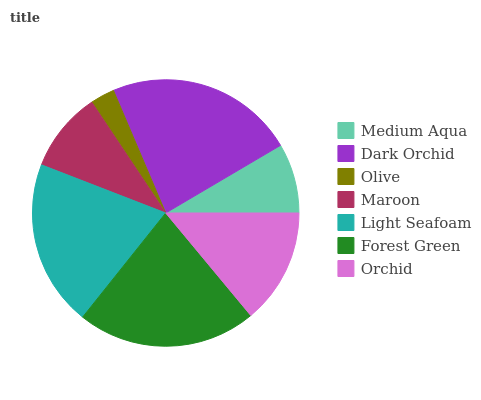Is Olive the minimum?
Answer yes or no. Yes. Is Dark Orchid the maximum?
Answer yes or no. Yes. Is Dark Orchid the minimum?
Answer yes or no. No. Is Olive the maximum?
Answer yes or no. No. Is Dark Orchid greater than Olive?
Answer yes or no. Yes. Is Olive less than Dark Orchid?
Answer yes or no. Yes. Is Olive greater than Dark Orchid?
Answer yes or no. No. Is Dark Orchid less than Olive?
Answer yes or no. No. Is Orchid the high median?
Answer yes or no. Yes. Is Orchid the low median?
Answer yes or no. Yes. Is Forest Green the high median?
Answer yes or no. No. Is Olive the low median?
Answer yes or no. No. 